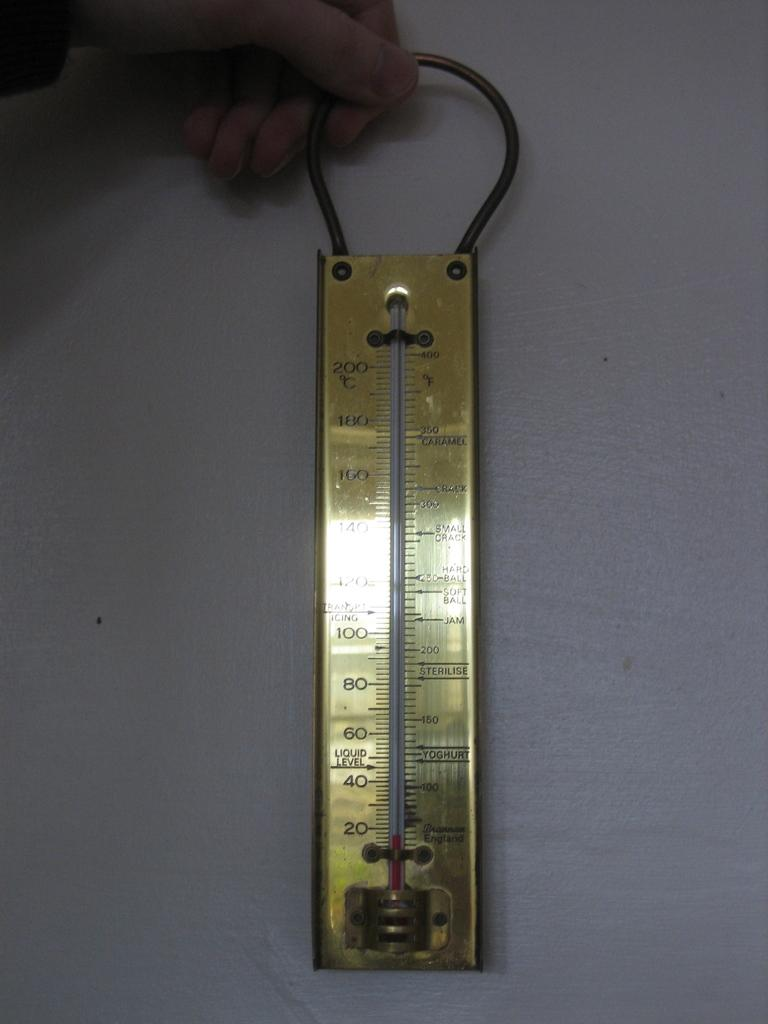<image>
Relay a brief, clear account of the picture shown. Thermometer that has the word "Caramel" on top. 